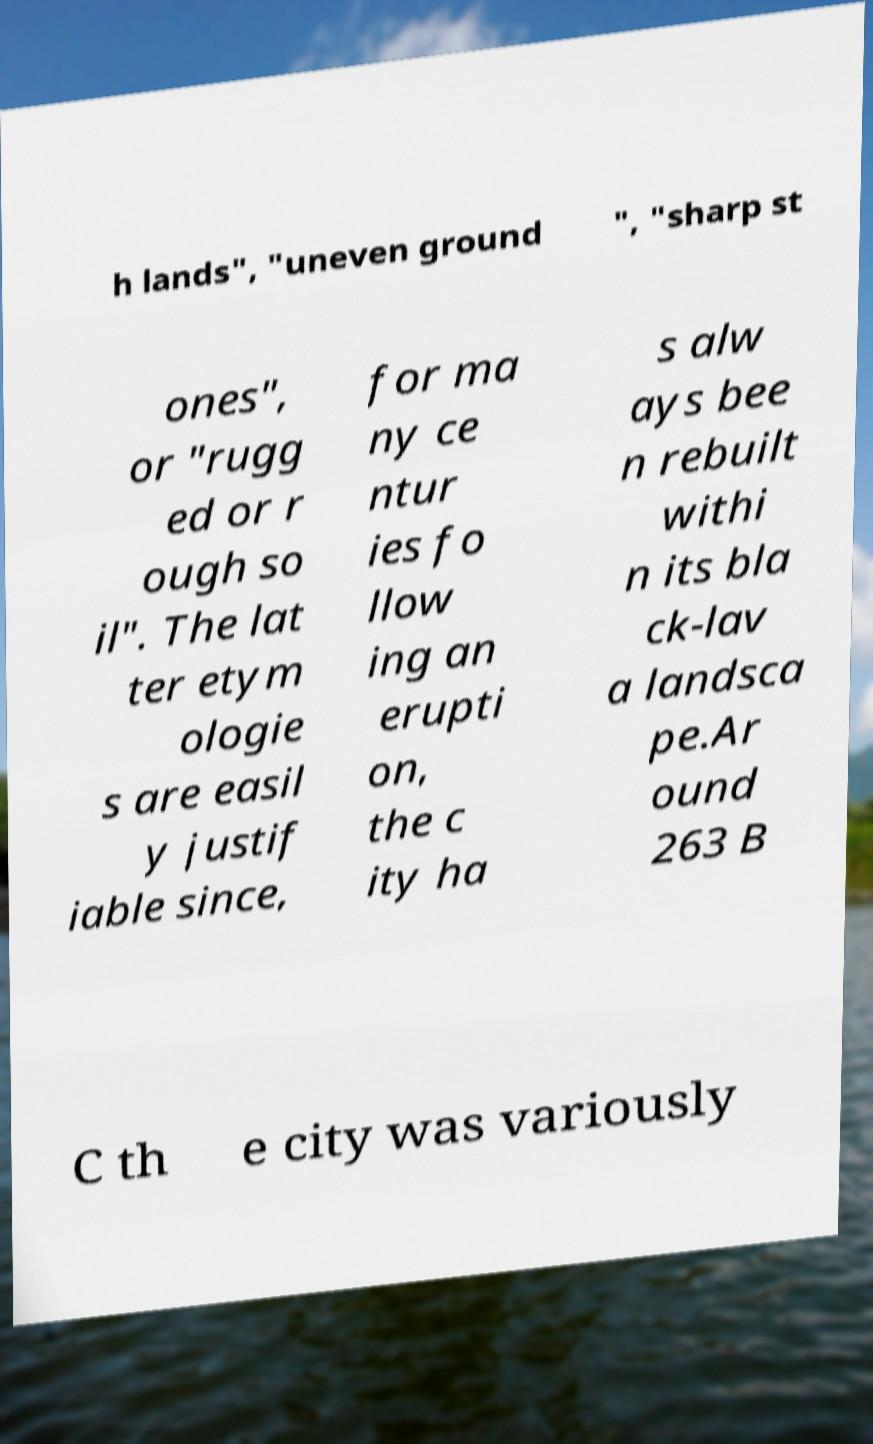For documentation purposes, I need the text within this image transcribed. Could you provide that? h lands", "uneven ground ", "sharp st ones", or "rugg ed or r ough so il". The lat ter etym ologie s are easil y justif iable since, for ma ny ce ntur ies fo llow ing an erupti on, the c ity ha s alw ays bee n rebuilt withi n its bla ck-lav a landsca pe.Ar ound 263 B C th e city was variously 